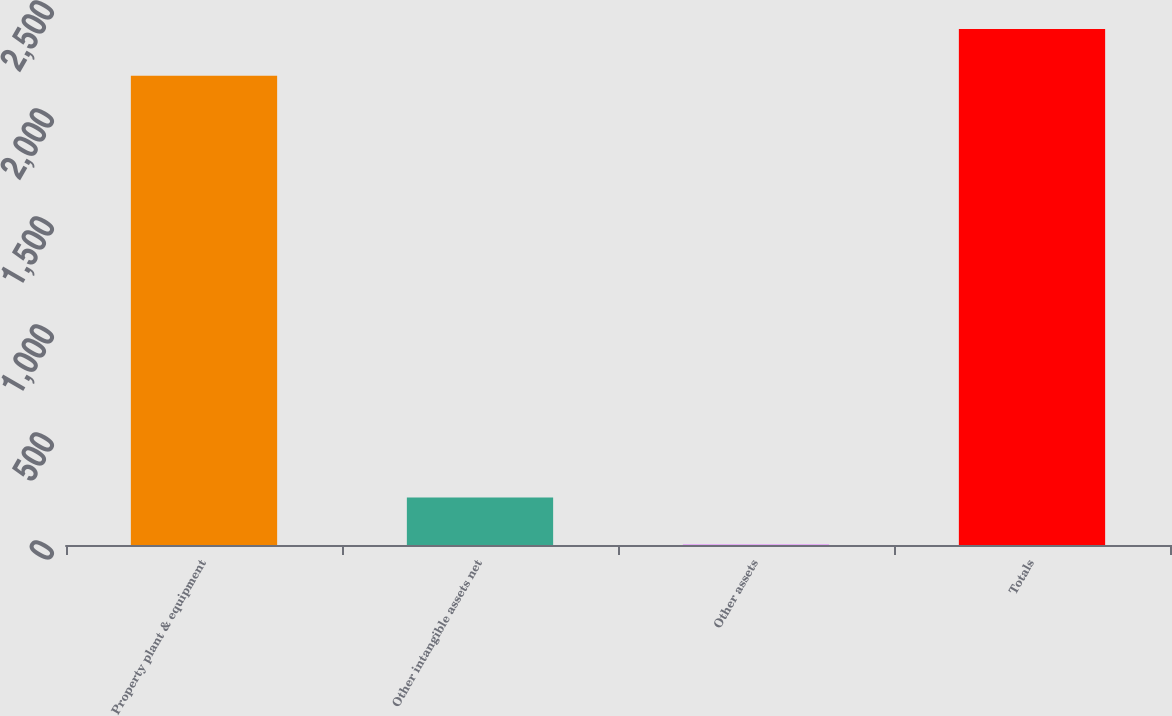Convert chart. <chart><loc_0><loc_0><loc_500><loc_500><bar_chart><fcel>Property plant & equipment<fcel>Other intangible assets net<fcel>Other assets<fcel>Totals<nl><fcel>2172<fcel>219.7<fcel>2.78<fcel>2388.92<nl></chart> 